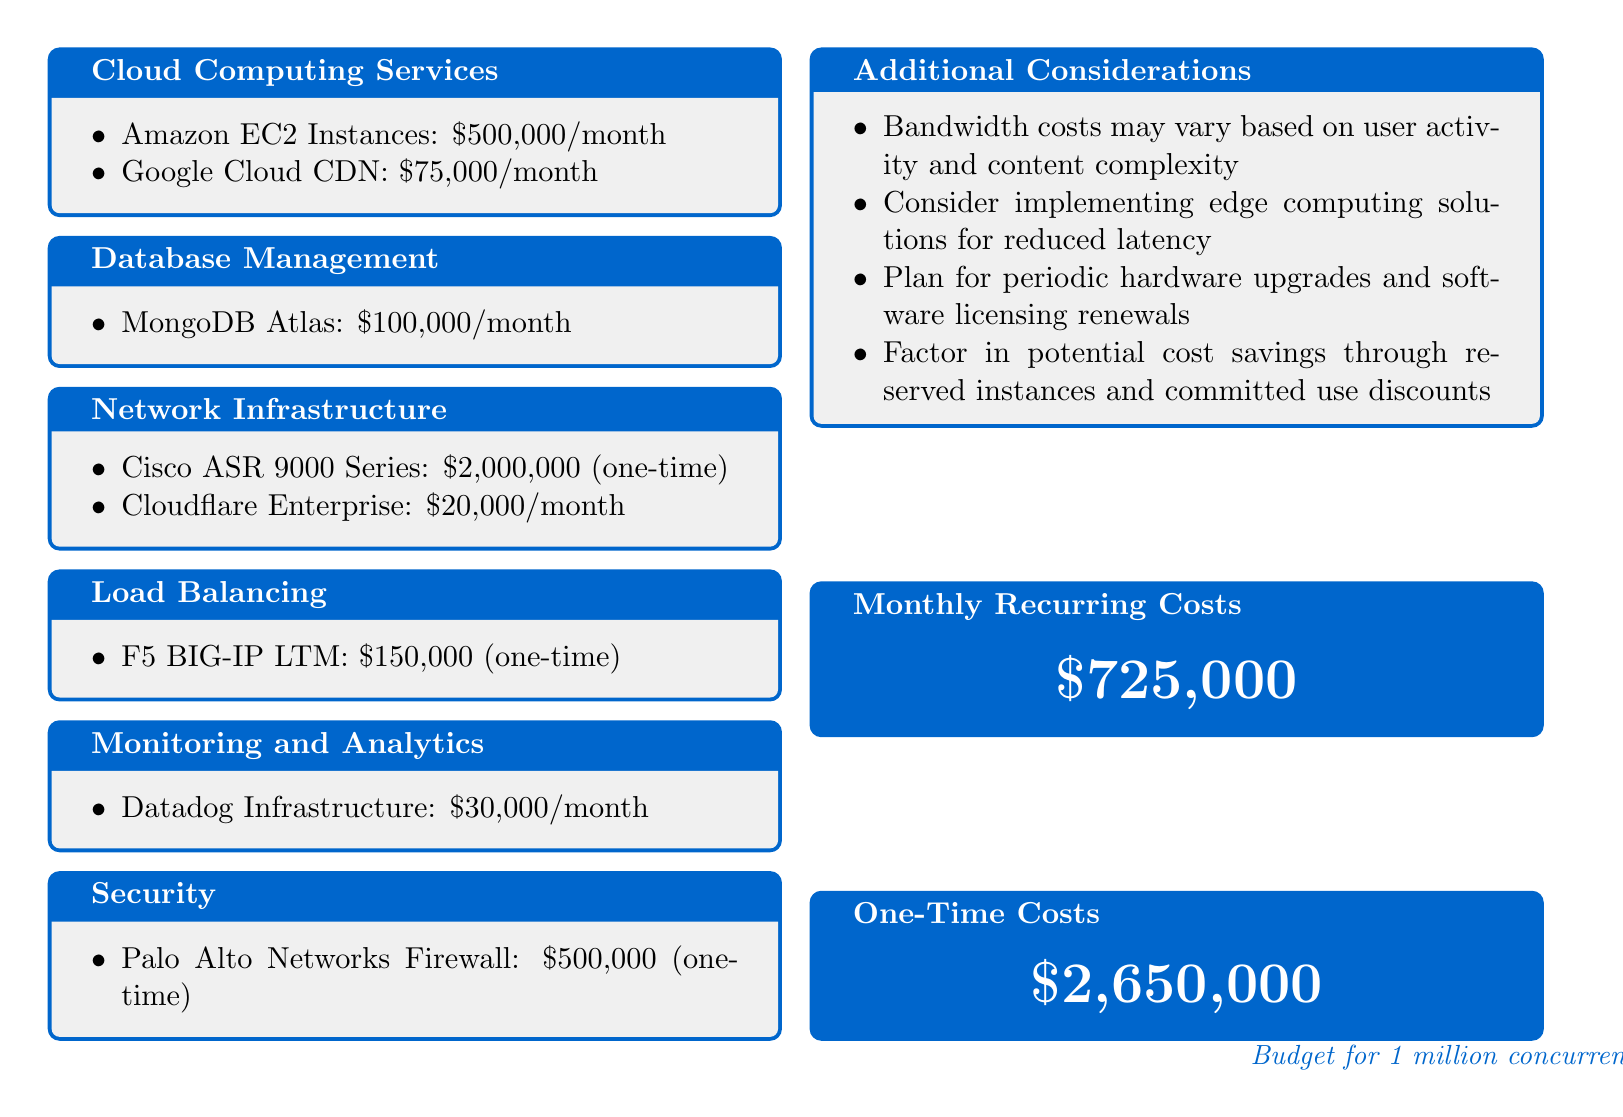What is the monthly cost for Amazon EC2 Instances? The document specifies that the monthly cost for Amazon EC2 Instances is provided under Cloud Computing Services.
Answer: $500,000/month What is the one-time cost for Cisco ASR 9000 Series? The document states the one-time cost for Cisco ASR 9000 Series, which falls under Network Infrastructure.
Answer: $2,000,000 What is the total monthly recurring cost for the server infrastructure? The total monthly recurring costs are summarized in a specific section of the document.
Answer: $725,000 How much is allocated for database management? The document explicitly lists the cost allocated for database management in the relevant section.
Answer: $100,000/month What is included in the additional considerations? The additional considerations section outlines potential factors for the server budget.
Answer: Bandwidth costs may vary based on user activity and content complexity What is the total one-time cost for security measures? The document gives the specific one-time cost for security under its relevant section.
Answer: $500,000 Which load balancing service is mentioned in the budget? The load balancing service is specified in the related budget section.
Answer: F5 BIG-IP LTM What might impact bandwidth costs according to the document? The document notes user activity and content complexity as factors affecting bandwidth costs.
Answer: User activity and content complexity 